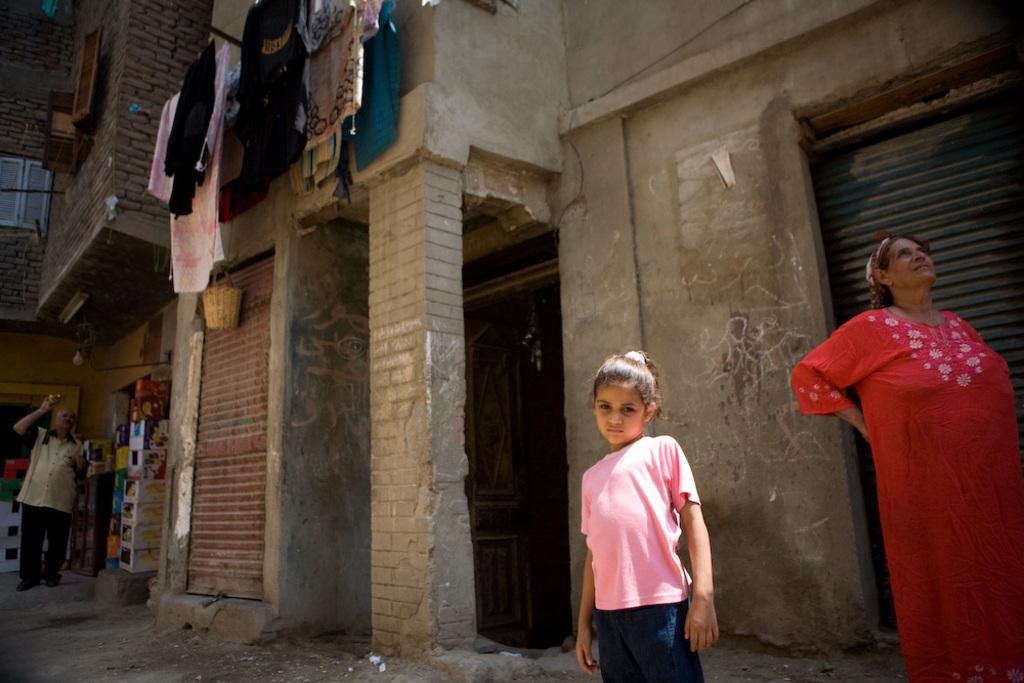Could you give a brief overview of what you see in this image? In this image there are some houses and some persons and there are some clothes which are hanging, in the center there is one shutter beside the shutter there are some boxes. On the shutter there is one basket, and at the bottom there is a walkway. 